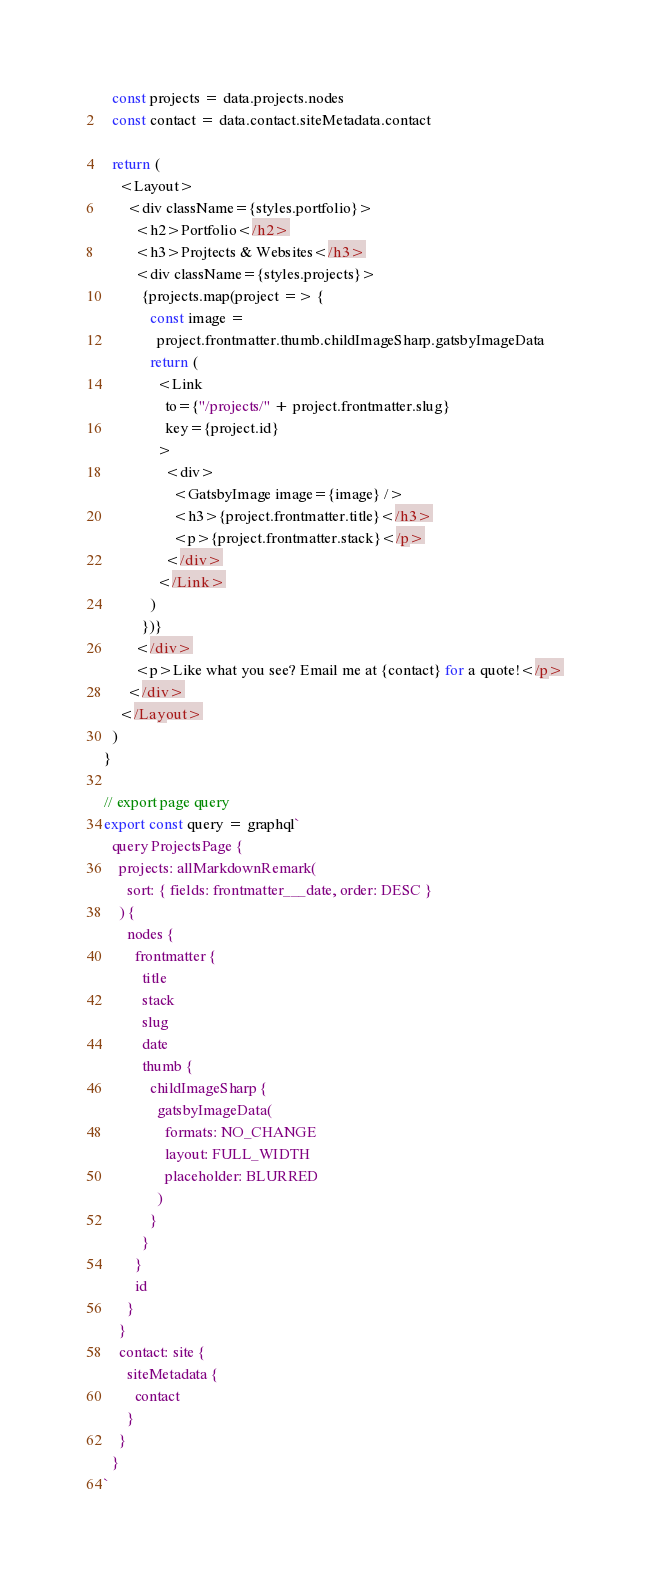<code> <loc_0><loc_0><loc_500><loc_500><_JavaScript_>  const projects = data.projects.nodes
  const contact = data.contact.siteMetadata.contact

  return (
    <Layout>
      <div className={styles.portfolio}>
        <h2>Portfolio</h2>
        <h3>Projtects & Websites</h3>
        <div className={styles.projects}>
          {projects.map(project => {
            const image =
              project.frontmatter.thumb.childImageSharp.gatsbyImageData
            return (
              <Link
                to={"/projects/" + project.frontmatter.slug}
                key={project.id}
              >
                <div>
                  <GatsbyImage image={image} />
                  <h3>{project.frontmatter.title}</h3>
                  <p>{project.frontmatter.stack}</p>
                </div>
              </Link>
            )
          })}
        </div>
        <p>Like what you see? Email me at {contact} for a quote!</p>
      </div>
    </Layout>
  )
}

// export page query
export const query = graphql`
  query ProjectsPage {
    projects: allMarkdownRemark(
      sort: { fields: frontmatter___date, order: DESC }
    ) {
      nodes {
        frontmatter {
          title
          stack
          slug
          date
          thumb {
            childImageSharp {
              gatsbyImageData(
                formats: NO_CHANGE
                layout: FULL_WIDTH
                placeholder: BLURRED
              )
            }
          }
        }
        id
      }
    }
    contact: site {
      siteMetadata {
        contact
      }
    }
  }
`
</code> 